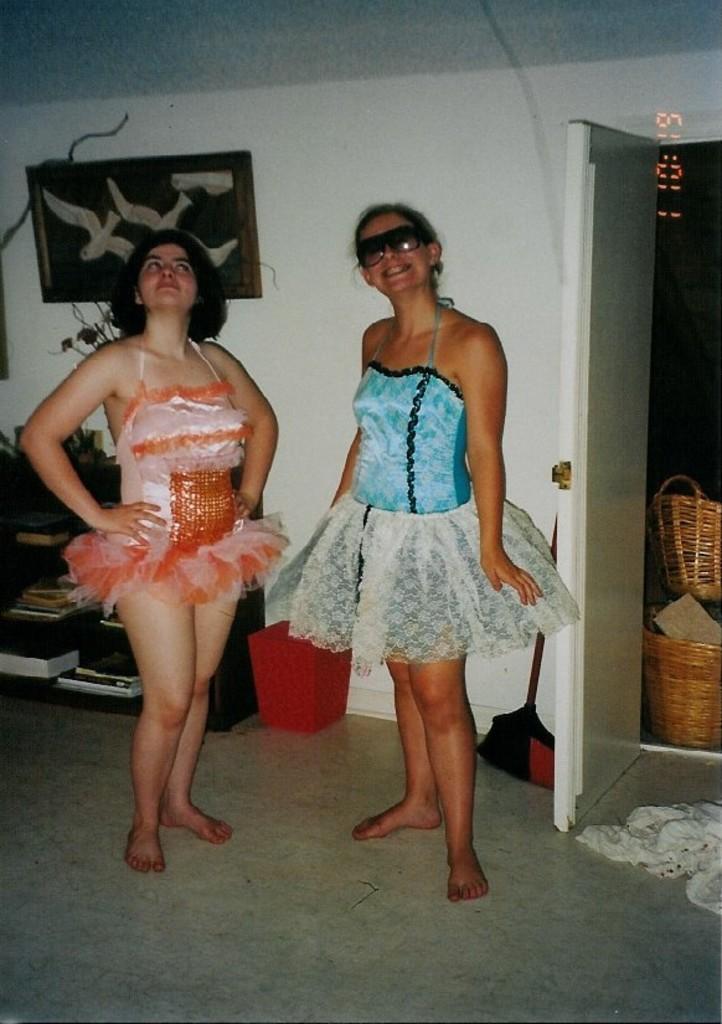In one or two sentences, can you explain what this image depicts? In this image there are two persons standing on the floor, there is a frame attached to the wall, few objects in the cupboard, a bin, a stick, door and some objects beside the door. 